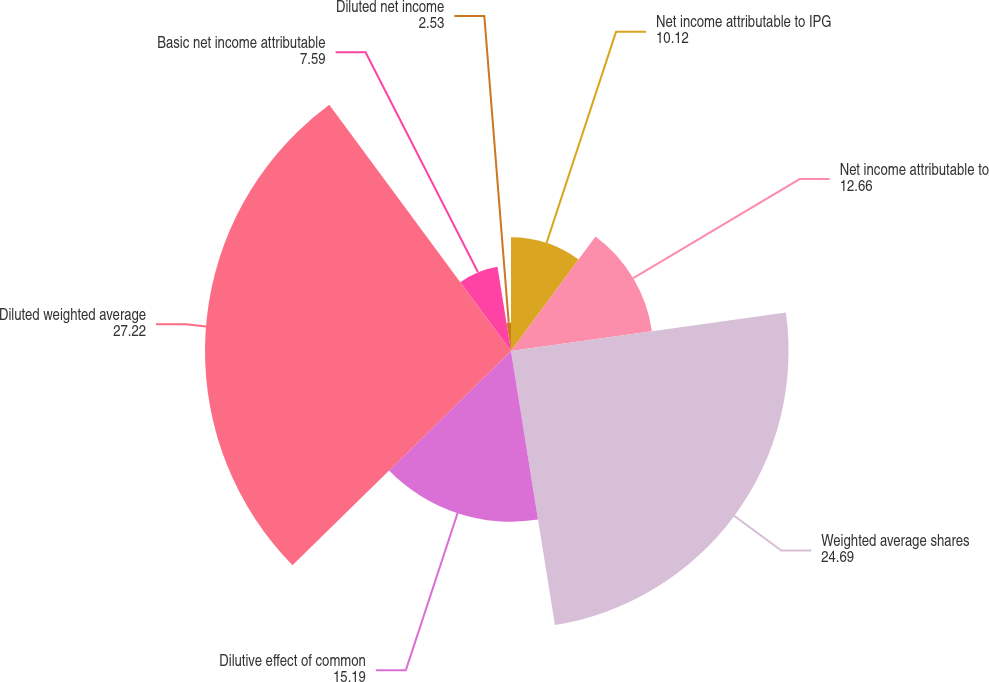<chart> <loc_0><loc_0><loc_500><loc_500><pie_chart><fcel>Net income attributable to IPG<fcel>Net income attributable to<fcel>Weighted average shares<fcel>Dilutive effect of common<fcel>Diluted weighted average<fcel>Basic net income attributable<fcel>Diluted net income<nl><fcel>10.12%<fcel>12.66%<fcel>24.69%<fcel>15.19%<fcel>27.22%<fcel>7.59%<fcel>2.53%<nl></chart> 